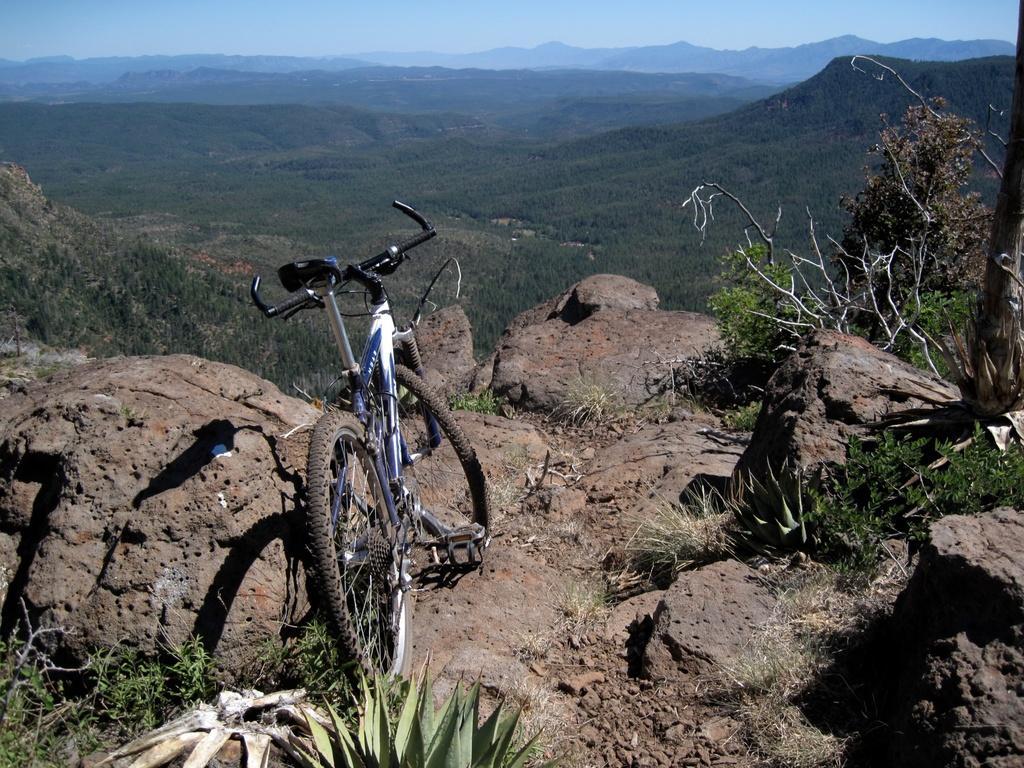How would you summarize this image in a sentence or two? In this picture we can see a bicycle. On the right side of the bicycle there are rocks and plants. In front of the bicycle there are hills and the sky. 